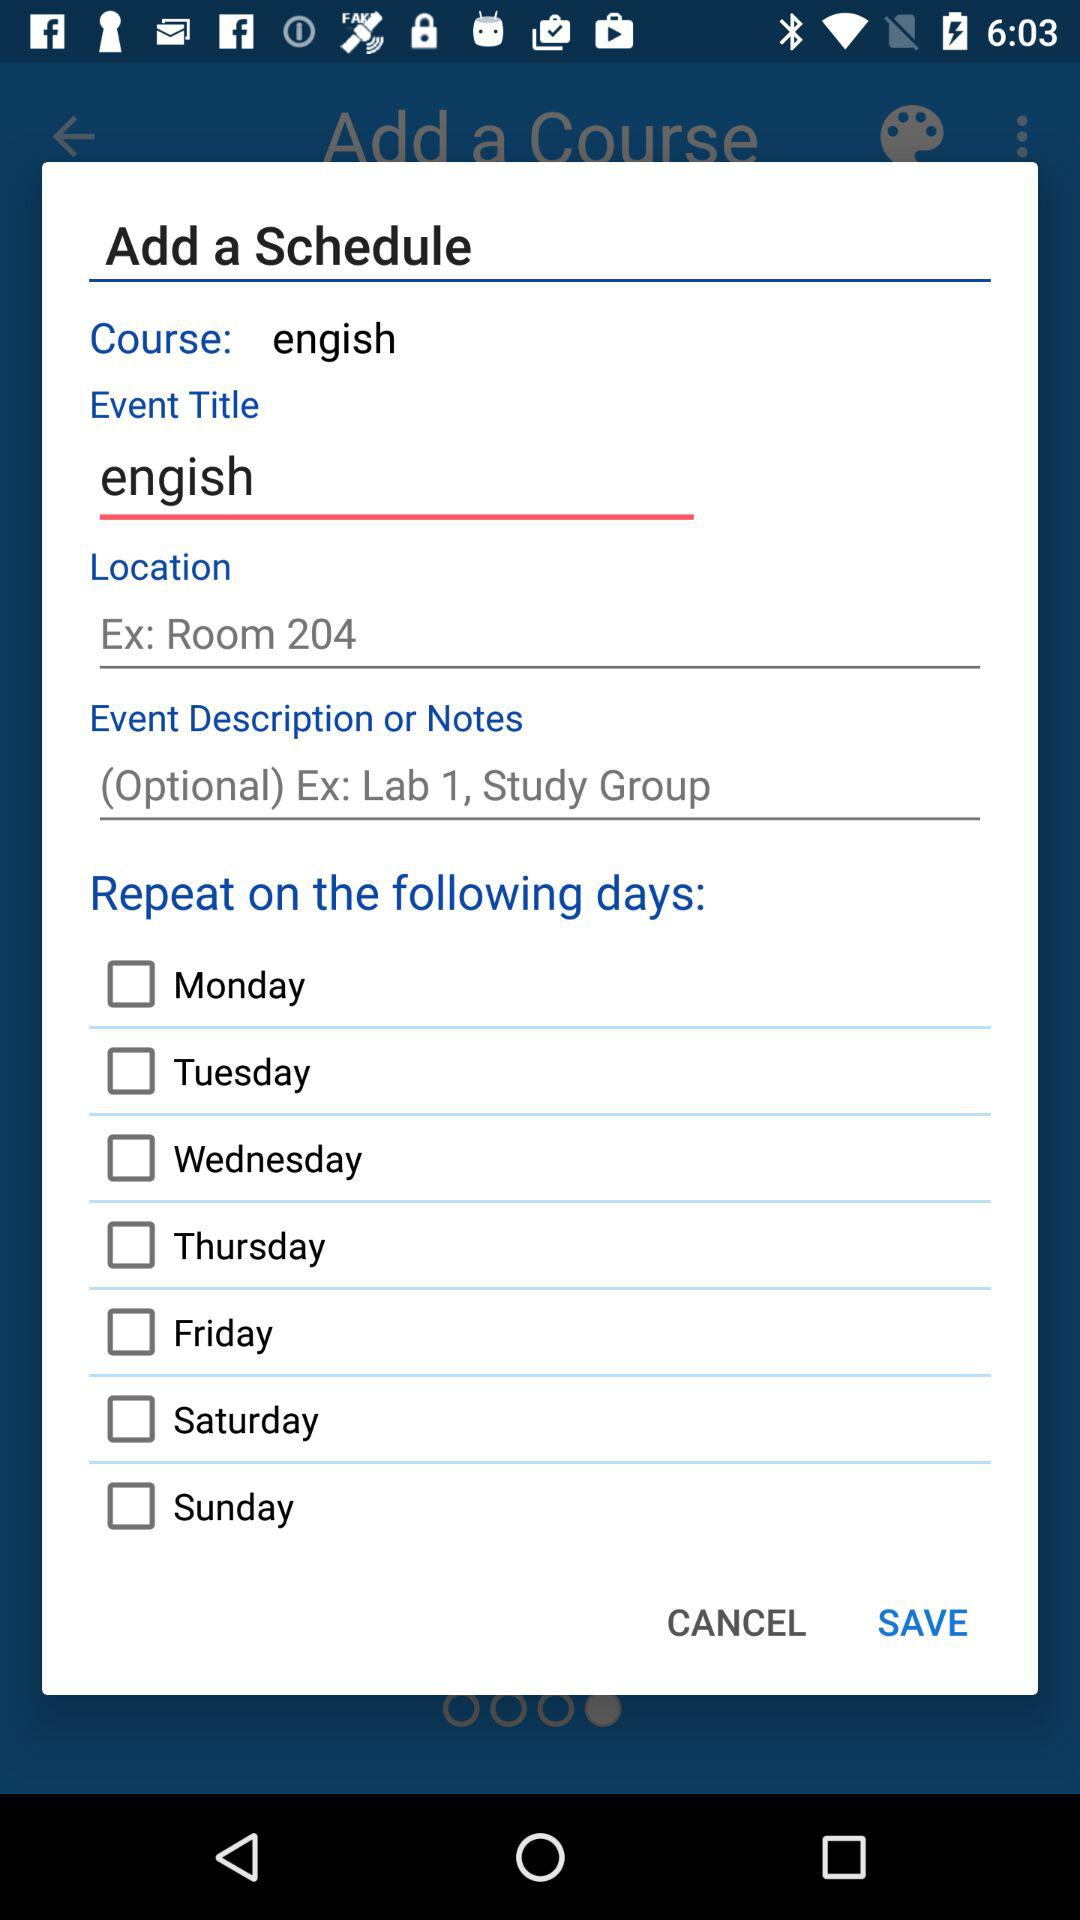What is the event's name? The event's name is "engish". 